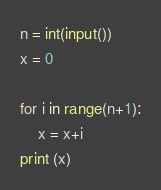<code> <loc_0><loc_0><loc_500><loc_500><_Python_>n = int(input())
x = 0

for i in range(n+1):
    x = x+i
print (x)</code> 